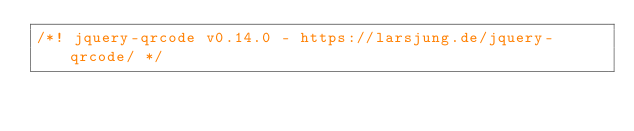Convert code to text. <code><loc_0><loc_0><loc_500><loc_500><_JavaScript_>/*! jquery-qrcode v0.14.0 - https://larsjung.de/jquery-qrcode/ */</code> 